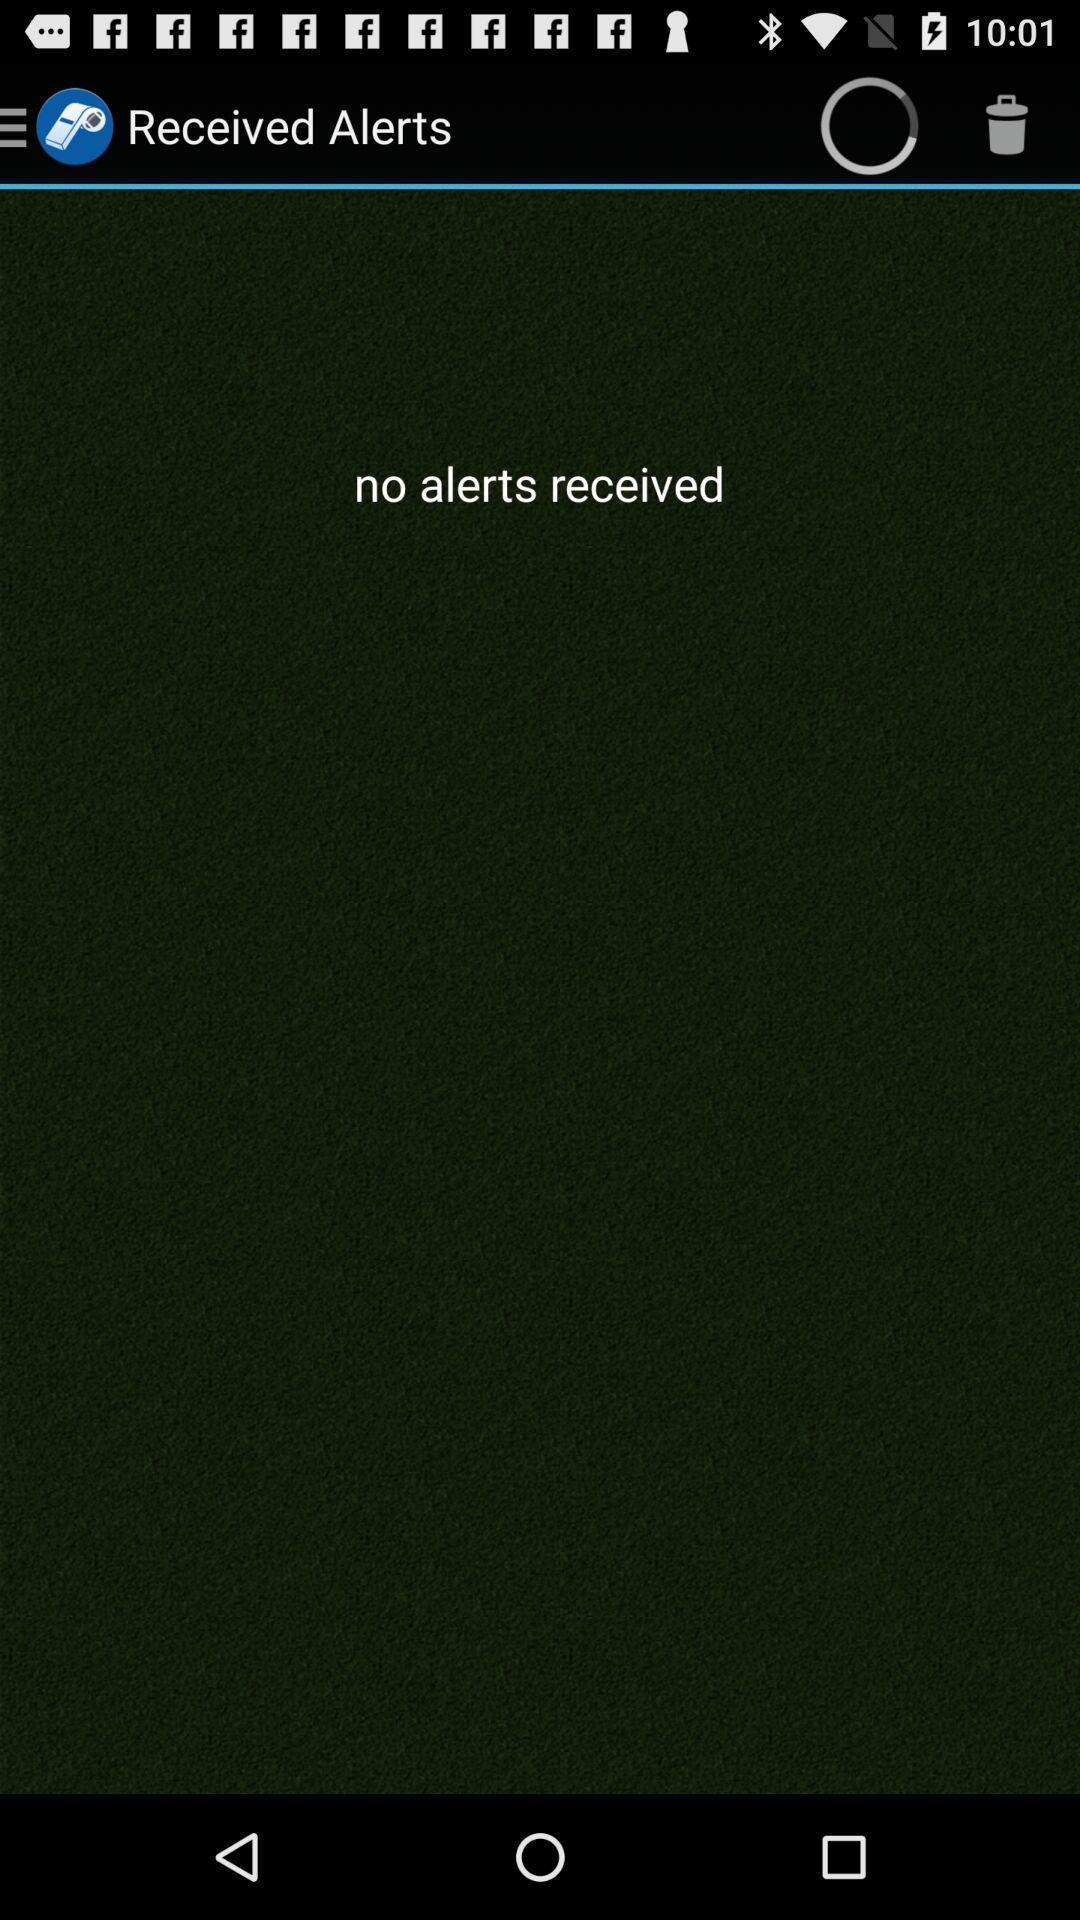What can you discern from this picture? Screen displaying alerts page. 